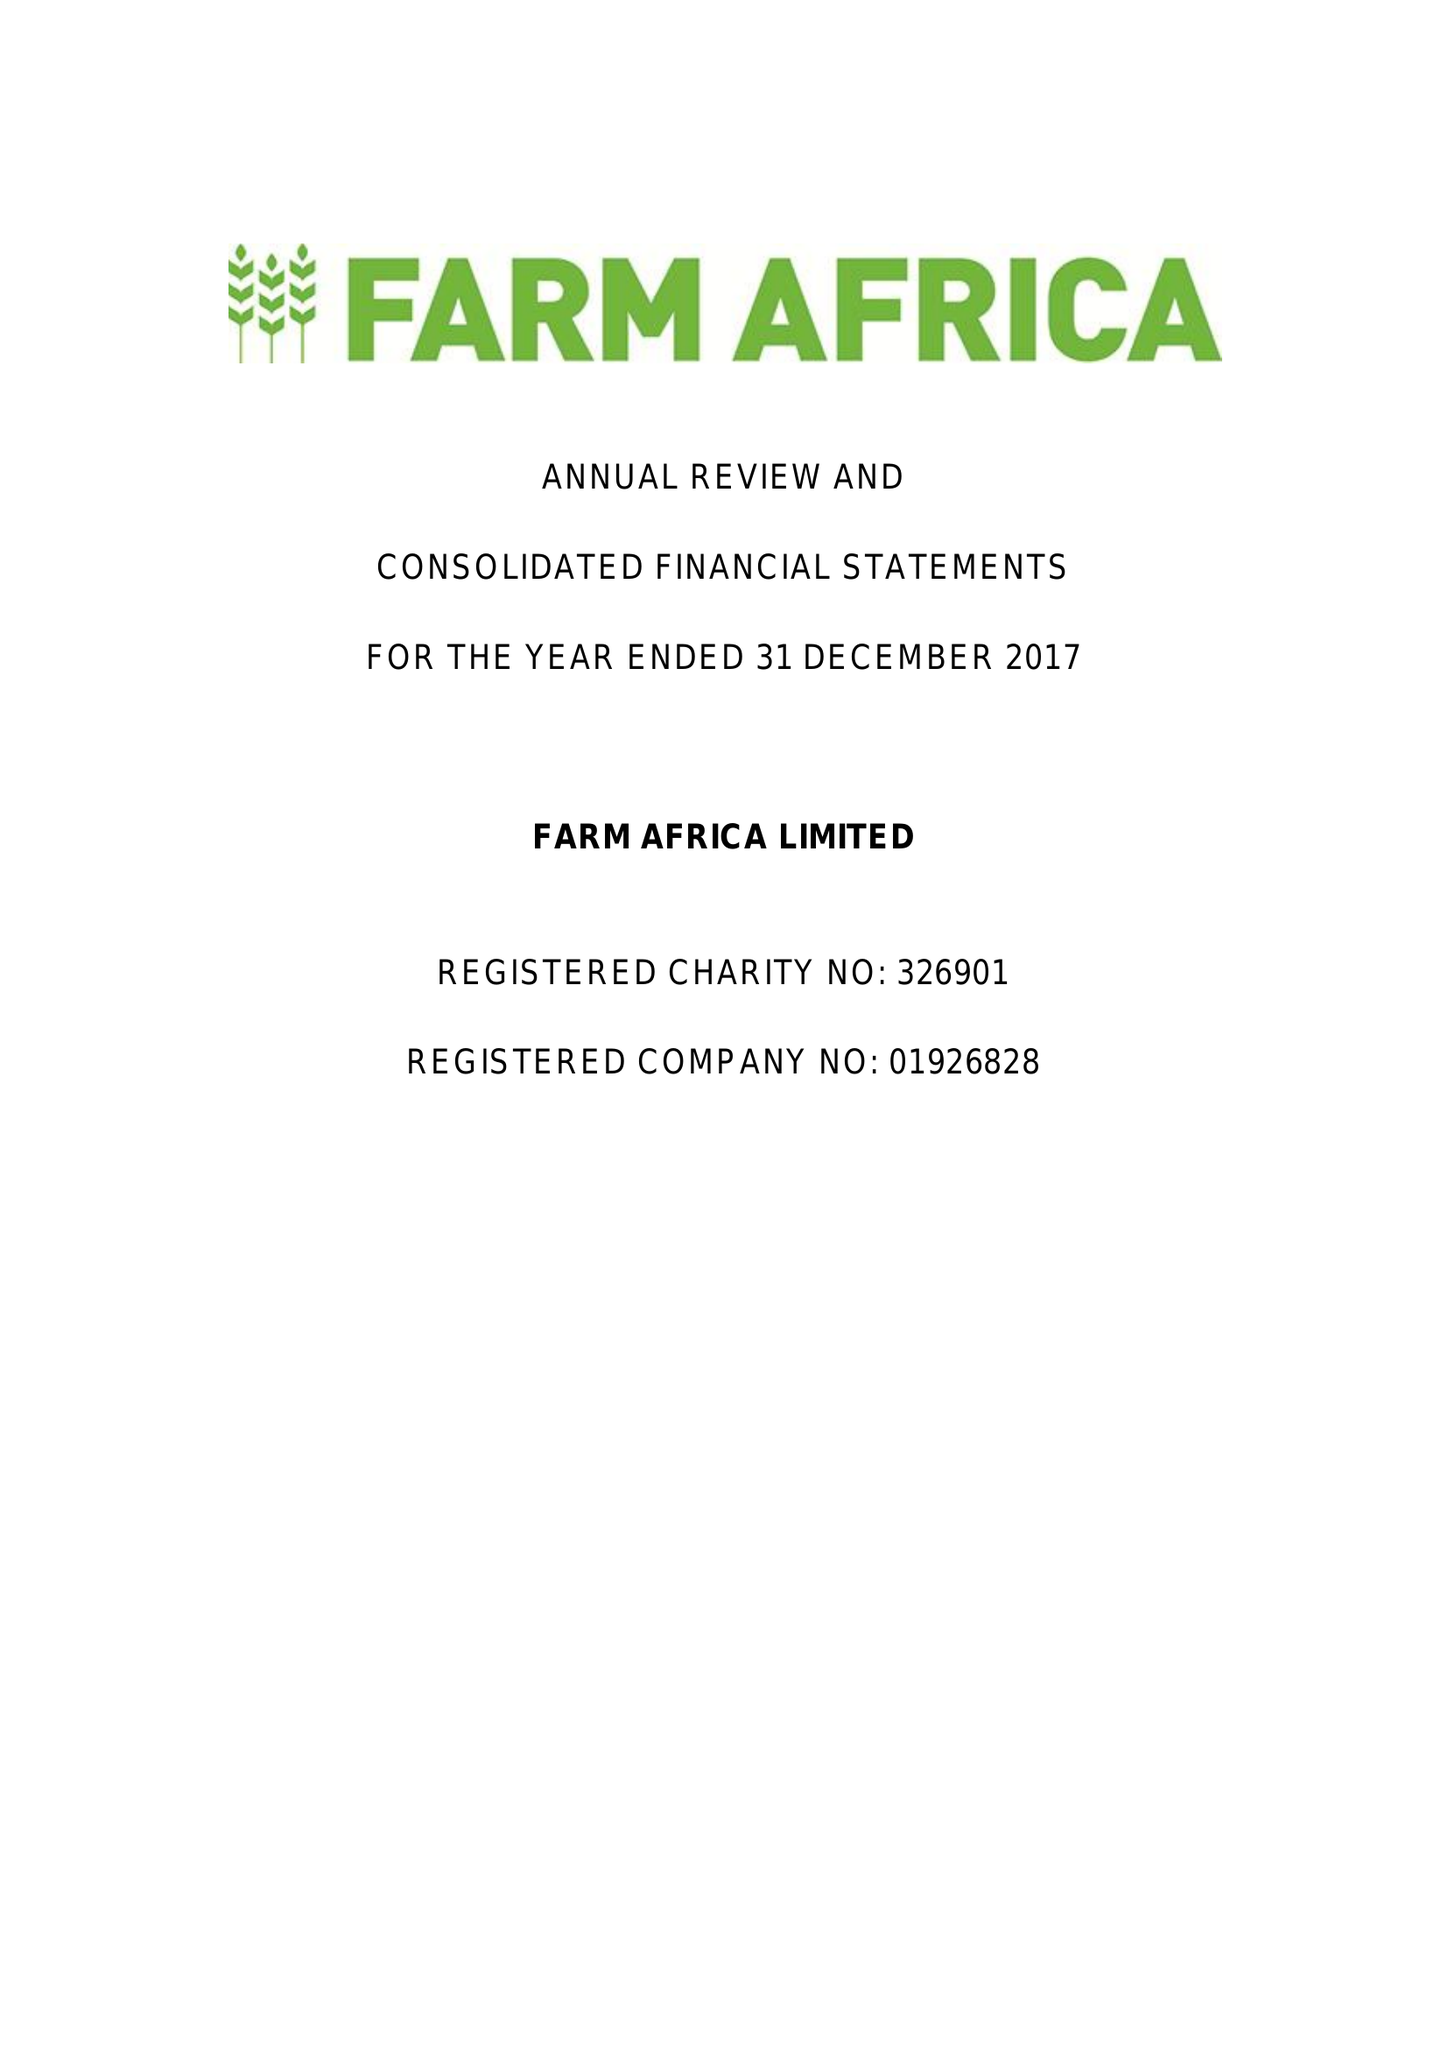What is the value for the address__post_town?
Answer the question using a single word or phrase. LONDON 